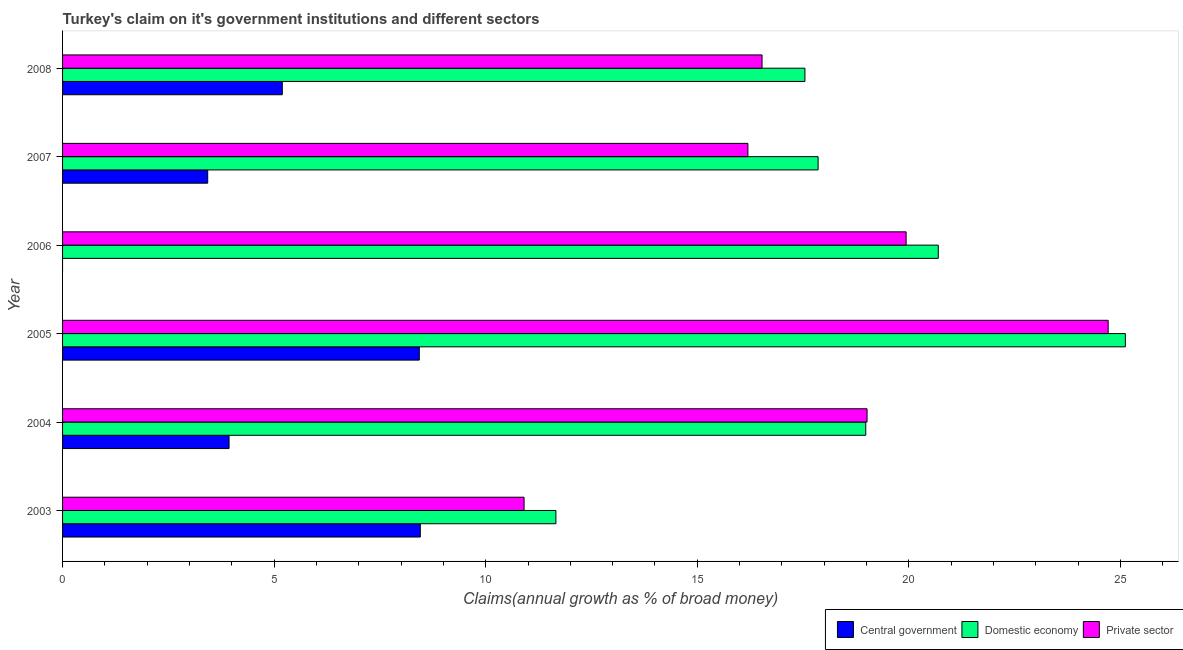How many groups of bars are there?
Give a very brief answer. 6. How many bars are there on the 6th tick from the bottom?
Provide a succinct answer. 3. What is the percentage of claim on the central government in 2007?
Provide a succinct answer. 3.43. Across all years, what is the maximum percentage of claim on the central government?
Make the answer very short. 8.45. What is the total percentage of claim on the domestic economy in the graph?
Provide a short and direct response. 111.86. What is the difference between the percentage of claim on the private sector in 2006 and that in 2008?
Offer a terse response. 3.4. What is the difference between the percentage of claim on the central government in 2008 and the percentage of claim on the private sector in 2003?
Offer a terse response. -5.71. What is the average percentage of claim on the domestic economy per year?
Keep it short and to the point. 18.64. In the year 2008, what is the difference between the percentage of claim on the central government and percentage of claim on the private sector?
Your answer should be compact. -11.34. In how many years, is the percentage of claim on the private sector greater than 8 %?
Offer a very short reply. 6. What is the ratio of the percentage of claim on the domestic economy in 2007 to that in 2008?
Make the answer very short. 1.02. What is the difference between the highest and the second highest percentage of claim on the domestic economy?
Make the answer very short. 4.42. In how many years, is the percentage of claim on the central government greater than the average percentage of claim on the central government taken over all years?
Offer a very short reply. 3. Is the sum of the percentage of claim on the private sector in 2003 and 2008 greater than the maximum percentage of claim on the domestic economy across all years?
Offer a terse response. Yes. How many years are there in the graph?
Make the answer very short. 6. What is the difference between two consecutive major ticks on the X-axis?
Ensure brevity in your answer.  5. Are the values on the major ticks of X-axis written in scientific E-notation?
Your response must be concise. No. Does the graph contain any zero values?
Offer a very short reply. Yes. Does the graph contain grids?
Give a very brief answer. No. Where does the legend appear in the graph?
Your response must be concise. Bottom right. What is the title of the graph?
Your answer should be compact. Turkey's claim on it's government institutions and different sectors. What is the label or title of the X-axis?
Provide a short and direct response. Claims(annual growth as % of broad money). What is the label or title of the Y-axis?
Give a very brief answer. Year. What is the Claims(annual growth as % of broad money) in Central government in 2003?
Ensure brevity in your answer.  8.45. What is the Claims(annual growth as % of broad money) of Domestic economy in 2003?
Your answer should be very brief. 11.66. What is the Claims(annual growth as % of broad money) of Private sector in 2003?
Offer a very short reply. 10.91. What is the Claims(annual growth as % of broad money) in Central government in 2004?
Provide a succinct answer. 3.93. What is the Claims(annual growth as % of broad money) of Domestic economy in 2004?
Provide a succinct answer. 18.98. What is the Claims(annual growth as % of broad money) of Private sector in 2004?
Offer a very short reply. 19.01. What is the Claims(annual growth as % of broad money) of Central government in 2005?
Offer a terse response. 8.43. What is the Claims(annual growth as % of broad money) in Domestic economy in 2005?
Ensure brevity in your answer.  25.12. What is the Claims(annual growth as % of broad money) of Private sector in 2005?
Provide a short and direct response. 24.71. What is the Claims(annual growth as % of broad money) of Domestic economy in 2006?
Provide a succinct answer. 20.7. What is the Claims(annual growth as % of broad money) of Private sector in 2006?
Keep it short and to the point. 19.94. What is the Claims(annual growth as % of broad money) in Central government in 2007?
Provide a short and direct response. 3.43. What is the Claims(annual growth as % of broad money) in Domestic economy in 2007?
Ensure brevity in your answer.  17.86. What is the Claims(annual growth as % of broad money) in Private sector in 2007?
Offer a very short reply. 16.2. What is the Claims(annual growth as % of broad money) of Central government in 2008?
Offer a very short reply. 5.19. What is the Claims(annual growth as % of broad money) in Domestic economy in 2008?
Give a very brief answer. 17.54. What is the Claims(annual growth as % of broad money) in Private sector in 2008?
Provide a succinct answer. 16.53. Across all years, what is the maximum Claims(annual growth as % of broad money) of Central government?
Offer a terse response. 8.45. Across all years, what is the maximum Claims(annual growth as % of broad money) of Domestic economy?
Offer a very short reply. 25.12. Across all years, what is the maximum Claims(annual growth as % of broad money) in Private sector?
Your answer should be compact. 24.71. Across all years, what is the minimum Claims(annual growth as % of broad money) of Central government?
Provide a succinct answer. 0. Across all years, what is the minimum Claims(annual growth as % of broad money) of Domestic economy?
Make the answer very short. 11.66. Across all years, what is the minimum Claims(annual growth as % of broad money) in Private sector?
Your answer should be very brief. 10.91. What is the total Claims(annual growth as % of broad money) in Central government in the graph?
Ensure brevity in your answer.  29.44. What is the total Claims(annual growth as % of broad money) of Domestic economy in the graph?
Make the answer very short. 111.86. What is the total Claims(annual growth as % of broad money) in Private sector in the graph?
Offer a very short reply. 107.3. What is the difference between the Claims(annual growth as % of broad money) of Central government in 2003 and that in 2004?
Offer a very short reply. 4.52. What is the difference between the Claims(annual growth as % of broad money) of Domestic economy in 2003 and that in 2004?
Your answer should be compact. -7.32. What is the difference between the Claims(annual growth as % of broad money) in Private sector in 2003 and that in 2004?
Keep it short and to the point. -8.11. What is the difference between the Claims(annual growth as % of broad money) of Central government in 2003 and that in 2005?
Give a very brief answer. 0.02. What is the difference between the Claims(annual growth as % of broad money) of Domestic economy in 2003 and that in 2005?
Keep it short and to the point. -13.46. What is the difference between the Claims(annual growth as % of broad money) in Private sector in 2003 and that in 2005?
Offer a terse response. -13.8. What is the difference between the Claims(annual growth as % of broad money) in Domestic economy in 2003 and that in 2006?
Give a very brief answer. -9.04. What is the difference between the Claims(annual growth as % of broad money) in Private sector in 2003 and that in 2006?
Your answer should be very brief. -9.03. What is the difference between the Claims(annual growth as % of broad money) in Central government in 2003 and that in 2007?
Your response must be concise. 5.02. What is the difference between the Claims(annual growth as % of broad money) in Domestic economy in 2003 and that in 2007?
Give a very brief answer. -6.2. What is the difference between the Claims(annual growth as % of broad money) in Private sector in 2003 and that in 2007?
Provide a succinct answer. -5.29. What is the difference between the Claims(annual growth as % of broad money) in Central government in 2003 and that in 2008?
Offer a very short reply. 3.26. What is the difference between the Claims(annual growth as % of broad money) of Domestic economy in 2003 and that in 2008?
Provide a short and direct response. -5.88. What is the difference between the Claims(annual growth as % of broad money) of Private sector in 2003 and that in 2008?
Offer a very short reply. -5.62. What is the difference between the Claims(annual growth as % of broad money) of Central government in 2004 and that in 2005?
Keep it short and to the point. -4.5. What is the difference between the Claims(annual growth as % of broad money) of Domestic economy in 2004 and that in 2005?
Your response must be concise. -6.14. What is the difference between the Claims(annual growth as % of broad money) in Private sector in 2004 and that in 2005?
Provide a short and direct response. -5.7. What is the difference between the Claims(annual growth as % of broad money) of Domestic economy in 2004 and that in 2006?
Your answer should be very brief. -1.71. What is the difference between the Claims(annual growth as % of broad money) in Private sector in 2004 and that in 2006?
Offer a terse response. -0.92. What is the difference between the Claims(annual growth as % of broad money) of Central government in 2004 and that in 2007?
Make the answer very short. 0.5. What is the difference between the Claims(annual growth as % of broad money) in Domestic economy in 2004 and that in 2007?
Provide a short and direct response. 1.13. What is the difference between the Claims(annual growth as % of broad money) of Private sector in 2004 and that in 2007?
Your response must be concise. 2.82. What is the difference between the Claims(annual growth as % of broad money) in Central government in 2004 and that in 2008?
Offer a very short reply. -1.26. What is the difference between the Claims(annual growth as % of broad money) of Domestic economy in 2004 and that in 2008?
Give a very brief answer. 1.44. What is the difference between the Claims(annual growth as % of broad money) in Private sector in 2004 and that in 2008?
Offer a terse response. 2.48. What is the difference between the Claims(annual growth as % of broad money) in Domestic economy in 2005 and that in 2006?
Offer a very short reply. 4.42. What is the difference between the Claims(annual growth as % of broad money) of Private sector in 2005 and that in 2006?
Provide a succinct answer. 4.78. What is the difference between the Claims(annual growth as % of broad money) in Central government in 2005 and that in 2007?
Your answer should be compact. 5. What is the difference between the Claims(annual growth as % of broad money) of Domestic economy in 2005 and that in 2007?
Make the answer very short. 7.26. What is the difference between the Claims(annual growth as % of broad money) of Private sector in 2005 and that in 2007?
Keep it short and to the point. 8.51. What is the difference between the Claims(annual growth as % of broad money) of Central government in 2005 and that in 2008?
Your answer should be compact. 3.24. What is the difference between the Claims(annual growth as % of broad money) in Domestic economy in 2005 and that in 2008?
Your answer should be very brief. 7.57. What is the difference between the Claims(annual growth as % of broad money) of Private sector in 2005 and that in 2008?
Offer a terse response. 8.18. What is the difference between the Claims(annual growth as % of broad money) of Domestic economy in 2006 and that in 2007?
Provide a succinct answer. 2.84. What is the difference between the Claims(annual growth as % of broad money) of Private sector in 2006 and that in 2007?
Ensure brevity in your answer.  3.74. What is the difference between the Claims(annual growth as % of broad money) of Domestic economy in 2006 and that in 2008?
Your answer should be very brief. 3.15. What is the difference between the Claims(annual growth as % of broad money) of Private sector in 2006 and that in 2008?
Offer a very short reply. 3.4. What is the difference between the Claims(annual growth as % of broad money) of Central government in 2007 and that in 2008?
Ensure brevity in your answer.  -1.76. What is the difference between the Claims(annual growth as % of broad money) of Domestic economy in 2007 and that in 2008?
Provide a short and direct response. 0.31. What is the difference between the Claims(annual growth as % of broad money) of Private sector in 2007 and that in 2008?
Ensure brevity in your answer.  -0.33. What is the difference between the Claims(annual growth as % of broad money) of Central government in 2003 and the Claims(annual growth as % of broad money) of Domestic economy in 2004?
Your response must be concise. -10.53. What is the difference between the Claims(annual growth as % of broad money) of Central government in 2003 and the Claims(annual growth as % of broad money) of Private sector in 2004?
Provide a succinct answer. -10.56. What is the difference between the Claims(annual growth as % of broad money) of Domestic economy in 2003 and the Claims(annual growth as % of broad money) of Private sector in 2004?
Your response must be concise. -7.35. What is the difference between the Claims(annual growth as % of broad money) of Central government in 2003 and the Claims(annual growth as % of broad money) of Domestic economy in 2005?
Offer a very short reply. -16.66. What is the difference between the Claims(annual growth as % of broad money) in Central government in 2003 and the Claims(annual growth as % of broad money) in Private sector in 2005?
Provide a succinct answer. -16.26. What is the difference between the Claims(annual growth as % of broad money) of Domestic economy in 2003 and the Claims(annual growth as % of broad money) of Private sector in 2005?
Provide a short and direct response. -13.05. What is the difference between the Claims(annual growth as % of broad money) of Central government in 2003 and the Claims(annual growth as % of broad money) of Domestic economy in 2006?
Give a very brief answer. -12.24. What is the difference between the Claims(annual growth as % of broad money) in Central government in 2003 and the Claims(annual growth as % of broad money) in Private sector in 2006?
Make the answer very short. -11.48. What is the difference between the Claims(annual growth as % of broad money) in Domestic economy in 2003 and the Claims(annual growth as % of broad money) in Private sector in 2006?
Offer a very short reply. -8.28. What is the difference between the Claims(annual growth as % of broad money) of Central government in 2003 and the Claims(annual growth as % of broad money) of Domestic economy in 2007?
Make the answer very short. -9.4. What is the difference between the Claims(annual growth as % of broad money) in Central government in 2003 and the Claims(annual growth as % of broad money) in Private sector in 2007?
Provide a succinct answer. -7.74. What is the difference between the Claims(annual growth as % of broad money) of Domestic economy in 2003 and the Claims(annual growth as % of broad money) of Private sector in 2007?
Make the answer very short. -4.54. What is the difference between the Claims(annual growth as % of broad money) of Central government in 2003 and the Claims(annual growth as % of broad money) of Domestic economy in 2008?
Your response must be concise. -9.09. What is the difference between the Claims(annual growth as % of broad money) of Central government in 2003 and the Claims(annual growth as % of broad money) of Private sector in 2008?
Offer a terse response. -8.08. What is the difference between the Claims(annual growth as % of broad money) in Domestic economy in 2003 and the Claims(annual growth as % of broad money) in Private sector in 2008?
Provide a succinct answer. -4.87. What is the difference between the Claims(annual growth as % of broad money) in Central government in 2004 and the Claims(annual growth as % of broad money) in Domestic economy in 2005?
Your response must be concise. -21.18. What is the difference between the Claims(annual growth as % of broad money) in Central government in 2004 and the Claims(annual growth as % of broad money) in Private sector in 2005?
Your response must be concise. -20.78. What is the difference between the Claims(annual growth as % of broad money) in Domestic economy in 2004 and the Claims(annual growth as % of broad money) in Private sector in 2005?
Your response must be concise. -5.73. What is the difference between the Claims(annual growth as % of broad money) in Central government in 2004 and the Claims(annual growth as % of broad money) in Domestic economy in 2006?
Offer a terse response. -16.76. What is the difference between the Claims(annual growth as % of broad money) in Central government in 2004 and the Claims(annual growth as % of broad money) in Private sector in 2006?
Ensure brevity in your answer.  -16. What is the difference between the Claims(annual growth as % of broad money) of Domestic economy in 2004 and the Claims(annual growth as % of broad money) of Private sector in 2006?
Your answer should be very brief. -0.95. What is the difference between the Claims(annual growth as % of broad money) of Central government in 2004 and the Claims(annual growth as % of broad money) of Domestic economy in 2007?
Provide a short and direct response. -13.92. What is the difference between the Claims(annual growth as % of broad money) in Central government in 2004 and the Claims(annual growth as % of broad money) in Private sector in 2007?
Ensure brevity in your answer.  -12.26. What is the difference between the Claims(annual growth as % of broad money) in Domestic economy in 2004 and the Claims(annual growth as % of broad money) in Private sector in 2007?
Offer a terse response. 2.79. What is the difference between the Claims(annual growth as % of broad money) of Central government in 2004 and the Claims(annual growth as % of broad money) of Domestic economy in 2008?
Make the answer very short. -13.61. What is the difference between the Claims(annual growth as % of broad money) of Central government in 2004 and the Claims(annual growth as % of broad money) of Private sector in 2008?
Ensure brevity in your answer.  -12.6. What is the difference between the Claims(annual growth as % of broad money) in Domestic economy in 2004 and the Claims(annual growth as % of broad money) in Private sector in 2008?
Keep it short and to the point. 2.45. What is the difference between the Claims(annual growth as % of broad money) in Central government in 2005 and the Claims(annual growth as % of broad money) in Domestic economy in 2006?
Offer a terse response. -12.27. What is the difference between the Claims(annual growth as % of broad money) of Central government in 2005 and the Claims(annual growth as % of broad money) of Private sector in 2006?
Offer a terse response. -11.51. What is the difference between the Claims(annual growth as % of broad money) of Domestic economy in 2005 and the Claims(annual growth as % of broad money) of Private sector in 2006?
Your answer should be compact. 5.18. What is the difference between the Claims(annual growth as % of broad money) of Central government in 2005 and the Claims(annual growth as % of broad money) of Domestic economy in 2007?
Make the answer very short. -9.43. What is the difference between the Claims(annual growth as % of broad money) of Central government in 2005 and the Claims(annual growth as % of broad money) of Private sector in 2007?
Offer a very short reply. -7.77. What is the difference between the Claims(annual growth as % of broad money) of Domestic economy in 2005 and the Claims(annual growth as % of broad money) of Private sector in 2007?
Provide a short and direct response. 8.92. What is the difference between the Claims(annual growth as % of broad money) of Central government in 2005 and the Claims(annual growth as % of broad money) of Domestic economy in 2008?
Your answer should be compact. -9.11. What is the difference between the Claims(annual growth as % of broad money) of Central government in 2005 and the Claims(annual growth as % of broad money) of Private sector in 2008?
Offer a terse response. -8.1. What is the difference between the Claims(annual growth as % of broad money) of Domestic economy in 2005 and the Claims(annual growth as % of broad money) of Private sector in 2008?
Provide a short and direct response. 8.59. What is the difference between the Claims(annual growth as % of broad money) of Domestic economy in 2006 and the Claims(annual growth as % of broad money) of Private sector in 2007?
Your answer should be compact. 4.5. What is the difference between the Claims(annual growth as % of broad money) in Domestic economy in 2006 and the Claims(annual growth as % of broad money) in Private sector in 2008?
Offer a very short reply. 4.17. What is the difference between the Claims(annual growth as % of broad money) in Central government in 2007 and the Claims(annual growth as % of broad money) in Domestic economy in 2008?
Provide a succinct answer. -14.11. What is the difference between the Claims(annual growth as % of broad money) of Central government in 2007 and the Claims(annual growth as % of broad money) of Private sector in 2008?
Offer a very short reply. -13.1. What is the difference between the Claims(annual growth as % of broad money) in Domestic economy in 2007 and the Claims(annual growth as % of broad money) in Private sector in 2008?
Provide a short and direct response. 1.32. What is the average Claims(annual growth as % of broad money) in Central government per year?
Keep it short and to the point. 4.91. What is the average Claims(annual growth as % of broad money) of Domestic economy per year?
Ensure brevity in your answer.  18.64. What is the average Claims(annual growth as % of broad money) of Private sector per year?
Make the answer very short. 17.88. In the year 2003, what is the difference between the Claims(annual growth as % of broad money) of Central government and Claims(annual growth as % of broad money) of Domestic economy?
Offer a terse response. -3.2. In the year 2003, what is the difference between the Claims(annual growth as % of broad money) in Central government and Claims(annual growth as % of broad money) in Private sector?
Offer a very short reply. -2.45. In the year 2003, what is the difference between the Claims(annual growth as % of broad money) of Domestic economy and Claims(annual growth as % of broad money) of Private sector?
Offer a terse response. 0.75. In the year 2004, what is the difference between the Claims(annual growth as % of broad money) in Central government and Claims(annual growth as % of broad money) in Domestic economy?
Your response must be concise. -15.05. In the year 2004, what is the difference between the Claims(annual growth as % of broad money) in Central government and Claims(annual growth as % of broad money) in Private sector?
Keep it short and to the point. -15.08. In the year 2004, what is the difference between the Claims(annual growth as % of broad money) of Domestic economy and Claims(annual growth as % of broad money) of Private sector?
Your answer should be compact. -0.03. In the year 2005, what is the difference between the Claims(annual growth as % of broad money) of Central government and Claims(annual growth as % of broad money) of Domestic economy?
Your answer should be compact. -16.69. In the year 2005, what is the difference between the Claims(annual growth as % of broad money) in Central government and Claims(annual growth as % of broad money) in Private sector?
Keep it short and to the point. -16.28. In the year 2005, what is the difference between the Claims(annual growth as % of broad money) in Domestic economy and Claims(annual growth as % of broad money) in Private sector?
Your answer should be compact. 0.41. In the year 2006, what is the difference between the Claims(annual growth as % of broad money) in Domestic economy and Claims(annual growth as % of broad money) in Private sector?
Offer a terse response. 0.76. In the year 2007, what is the difference between the Claims(annual growth as % of broad money) of Central government and Claims(annual growth as % of broad money) of Domestic economy?
Keep it short and to the point. -14.43. In the year 2007, what is the difference between the Claims(annual growth as % of broad money) in Central government and Claims(annual growth as % of broad money) in Private sector?
Make the answer very short. -12.77. In the year 2007, what is the difference between the Claims(annual growth as % of broad money) of Domestic economy and Claims(annual growth as % of broad money) of Private sector?
Provide a succinct answer. 1.66. In the year 2008, what is the difference between the Claims(annual growth as % of broad money) in Central government and Claims(annual growth as % of broad money) in Domestic economy?
Ensure brevity in your answer.  -12.35. In the year 2008, what is the difference between the Claims(annual growth as % of broad money) of Central government and Claims(annual growth as % of broad money) of Private sector?
Keep it short and to the point. -11.34. In the year 2008, what is the difference between the Claims(annual growth as % of broad money) in Domestic economy and Claims(annual growth as % of broad money) in Private sector?
Offer a terse response. 1.01. What is the ratio of the Claims(annual growth as % of broad money) of Central government in 2003 to that in 2004?
Offer a very short reply. 2.15. What is the ratio of the Claims(annual growth as % of broad money) in Domestic economy in 2003 to that in 2004?
Give a very brief answer. 0.61. What is the ratio of the Claims(annual growth as % of broad money) of Private sector in 2003 to that in 2004?
Make the answer very short. 0.57. What is the ratio of the Claims(annual growth as % of broad money) of Central government in 2003 to that in 2005?
Your answer should be very brief. 1. What is the ratio of the Claims(annual growth as % of broad money) in Domestic economy in 2003 to that in 2005?
Make the answer very short. 0.46. What is the ratio of the Claims(annual growth as % of broad money) in Private sector in 2003 to that in 2005?
Your response must be concise. 0.44. What is the ratio of the Claims(annual growth as % of broad money) of Domestic economy in 2003 to that in 2006?
Your answer should be very brief. 0.56. What is the ratio of the Claims(annual growth as % of broad money) of Private sector in 2003 to that in 2006?
Provide a succinct answer. 0.55. What is the ratio of the Claims(annual growth as % of broad money) in Central government in 2003 to that in 2007?
Your answer should be compact. 2.46. What is the ratio of the Claims(annual growth as % of broad money) of Domestic economy in 2003 to that in 2007?
Give a very brief answer. 0.65. What is the ratio of the Claims(annual growth as % of broad money) in Private sector in 2003 to that in 2007?
Ensure brevity in your answer.  0.67. What is the ratio of the Claims(annual growth as % of broad money) of Central government in 2003 to that in 2008?
Your response must be concise. 1.63. What is the ratio of the Claims(annual growth as % of broad money) of Domestic economy in 2003 to that in 2008?
Your answer should be compact. 0.66. What is the ratio of the Claims(annual growth as % of broad money) in Private sector in 2003 to that in 2008?
Make the answer very short. 0.66. What is the ratio of the Claims(annual growth as % of broad money) of Central government in 2004 to that in 2005?
Your response must be concise. 0.47. What is the ratio of the Claims(annual growth as % of broad money) of Domestic economy in 2004 to that in 2005?
Provide a succinct answer. 0.76. What is the ratio of the Claims(annual growth as % of broad money) in Private sector in 2004 to that in 2005?
Provide a succinct answer. 0.77. What is the ratio of the Claims(annual growth as % of broad money) of Domestic economy in 2004 to that in 2006?
Offer a terse response. 0.92. What is the ratio of the Claims(annual growth as % of broad money) of Private sector in 2004 to that in 2006?
Your answer should be compact. 0.95. What is the ratio of the Claims(annual growth as % of broad money) of Central government in 2004 to that in 2007?
Make the answer very short. 1.15. What is the ratio of the Claims(annual growth as % of broad money) of Domestic economy in 2004 to that in 2007?
Your response must be concise. 1.06. What is the ratio of the Claims(annual growth as % of broad money) of Private sector in 2004 to that in 2007?
Your answer should be very brief. 1.17. What is the ratio of the Claims(annual growth as % of broad money) in Central government in 2004 to that in 2008?
Your answer should be very brief. 0.76. What is the ratio of the Claims(annual growth as % of broad money) in Domestic economy in 2004 to that in 2008?
Your answer should be very brief. 1.08. What is the ratio of the Claims(annual growth as % of broad money) of Private sector in 2004 to that in 2008?
Offer a terse response. 1.15. What is the ratio of the Claims(annual growth as % of broad money) of Domestic economy in 2005 to that in 2006?
Offer a very short reply. 1.21. What is the ratio of the Claims(annual growth as % of broad money) of Private sector in 2005 to that in 2006?
Make the answer very short. 1.24. What is the ratio of the Claims(annual growth as % of broad money) in Central government in 2005 to that in 2007?
Ensure brevity in your answer.  2.46. What is the ratio of the Claims(annual growth as % of broad money) in Domestic economy in 2005 to that in 2007?
Your answer should be compact. 1.41. What is the ratio of the Claims(annual growth as % of broad money) in Private sector in 2005 to that in 2007?
Make the answer very short. 1.53. What is the ratio of the Claims(annual growth as % of broad money) of Central government in 2005 to that in 2008?
Your answer should be very brief. 1.62. What is the ratio of the Claims(annual growth as % of broad money) in Domestic economy in 2005 to that in 2008?
Your answer should be very brief. 1.43. What is the ratio of the Claims(annual growth as % of broad money) in Private sector in 2005 to that in 2008?
Offer a very short reply. 1.49. What is the ratio of the Claims(annual growth as % of broad money) of Domestic economy in 2006 to that in 2007?
Offer a very short reply. 1.16. What is the ratio of the Claims(annual growth as % of broad money) of Private sector in 2006 to that in 2007?
Make the answer very short. 1.23. What is the ratio of the Claims(annual growth as % of broad money) in Domestic economy in 2006 to that in 2008?
Your answer should be very brief. 1.18. What is the ratio of the Claims(annual growth as % of broad money) of Private sector in 2006 to that in 2008?
Provide a succinct answer. 1.21. What is the ratio of the Claims(annual growth as % of broad money) of Central government in 2007 to that in 2008?
Make the answer very short. 0.66. What is the ratio of the Claims(annual growth as % of broad money) in Domestic economy in 2007 to that in 2008?
Make the answer very short. 1.02. What is the ratio of the Claims(annual growth as % of broad money) in Private sector in 2007 to that in 2008?
Offer a terse response. 0.98. What is the difference between the highest and the second highest Claims(annual growth as % of broad money) of Central government?
Keep it short and to the point. 0.02. What is the difference between the highest and the second highest Claims(annual growth as % of broad money) of Domestic economy?
Your response must be concise. 4.42. What is the difference between the highest and the second highest Claims(annual growth as % of broad money) in Private sector?
Give a very brief answer. 4.78. What is the difference between the highest and the lowest Claims(annual growth as % of broad money) of Central government?
Make the answer very short. 8.45. What is the difference between the highest and the lowest Claims(annual growth as % of broad money) of Domestic economy?
Make the answer very short. 13.46. What is the difference between the highest and the lowest Claims(annual growth as % of broad money) in Private sector?
Give a very brief answer. 13.8. 